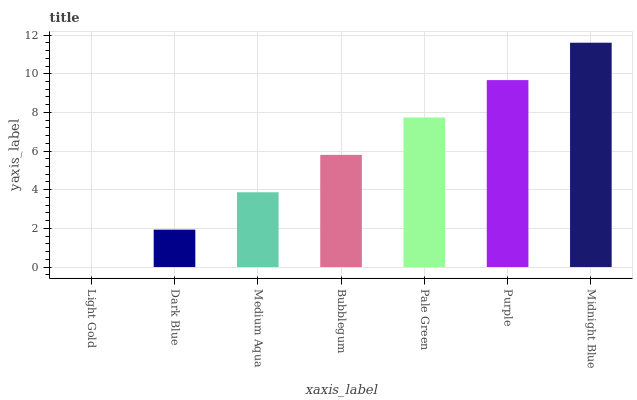Is Light Gold the minimum?
Answer yes or no. Yes. Is Midnight Blue the maximum?
Answer yes or no. Yes. Is Dark Blue the minimum?
Answer yes or no. No. Is Dark Blue the maximum?
Answer yes or no. No. Is Dark Blue greater than Light Gold?
Answer yes or no. Yes. Is Light Gold less than Dark Blue?
Answer yes or no. Yes. Is Light Gold greater than Dark Blue?
Answer yes or no. No. Is Dark Blue less than Light Gold?
Answer yes or no. No. Is Bubblegum the high median?
Answer yes or no. Yes. Is Bubblegum the low median?
Answer yes or no. Yes. Is Pale Green the high median?
Answer yes or no. No. Is Pale Green the low median?
Answer yes or no. No. 